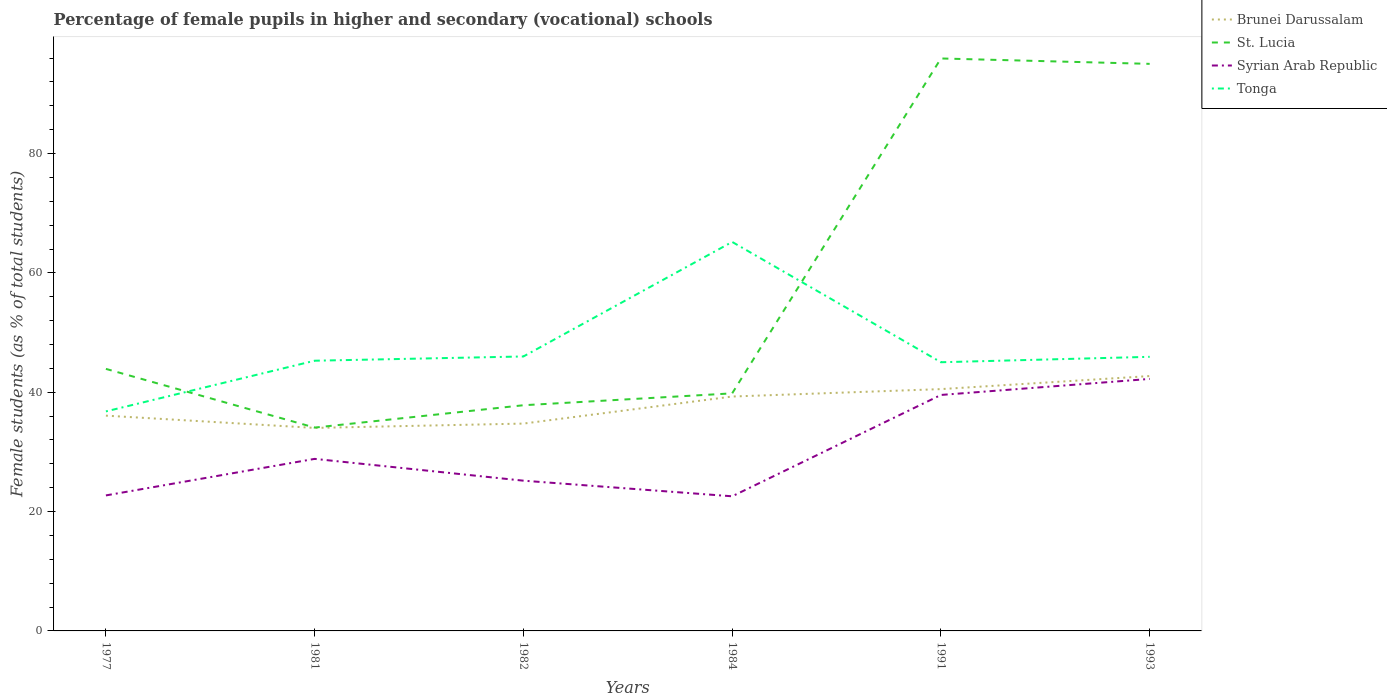How many different coloured lines are there?
Keep it short and to the point. 4. Across all years, what is the maximum percentage of female pupils in higher and secondary schools in St. Lucia?
Give a very brief answer. 34.08. In which year was the percentage of female pupils in higher and secondary schools in St. Lucia maximum?
Provide a short and direct response. 1981. What is the total percentage of female pupils in higher and secondary schools in St. Lucia in the graph?
Make the answer very short. -51.12. What is the difference between the highest and the second highest percentage of female pupils in higher and secondary schools in St. Lucia?
Make the answer very short. 61.86. What is the difference between the highest and the lowest percentage of female pupils in higher and secondary schools in Brunei Darussalam?
Offer a very short reply. 3. How many lines are there?
Make the answer very short. 4. Are the values on the major ticks of Y-axis written in scientific E-notation?
Provide a succinct answer. No. Does the graph contain grids?
Ensure brevity in your answer.  No. How many legend labels are there?
Offer a terse response. 4. What is the title of the graph?
Provide a short and direct response. Percentage of female pupils in higher and secondary (vocational) schools. Does "Italy" appear as one of the legend labels in the graph?
Your answer should be very brief. No. What is the label or title of the X-axis?
Provide a short and direct response. Years. What is the label or title of the Y-axis?
Provide a succinct answer. Female students (as % of total students). What is the Female students (as % of total students) in Brunei Darussalam in 1977?
Provide a succinct answer. 36.08. What is the Female students (as % of total students) in St. Lucia in 1977?
Give a very brief answer. 43.92. What is the Female students (as % of total students) of Syrian Arab Republic in 1977?
Give a very brief answer. 22.71. What is the Female students (as % of total students) in Tonga in 1977?
Your answer should be compact. 36.79. What is the Female students (as % of total students) of Brunei Darussalam in 1981?
Ensure brevity in your answer.  34.02. What is the Female students (as % of total students) of St. Lucia in 1981?
Provide a succinct answer. 34.08. What is the Female students (as % of total students) of Syrian Arab Republic in 1981?
Keep it short and to the point. 28.83. What is the Female students (as % of total students) of Tonga in 1981?
Offer a terse response. 45.29. What is the Female students (as % of total students) in Brunei Darussalam in 1982?
Your response must be concise. 34.75. What is the Female students (as % of total students) of St. Lucia in 1982?
Ensure brevity in your answer.  37.82. What is the Female students (as % of total students) of Syrian Arab Republic in 1982?
Make the answer very short. 25.18. What is the Female students (as % of total students) of Tonga in 1982?
Provide a short and direct response. 46. What is the Female students (as % of total students) in Brunei Darussalam in 1984?
Your response must be concise. 39.28. What is the Female students (as % of total students) in St. Lucia in 1984?
Provide a short and direct response. 39.81. What is the Female students (as % of total students) in Syrian Arab Republic in 1984?
Your response must be concise. 22.56. What is the Female students (as % of total students) of Tonga in 1984?
Your answer should be very brief. 65.19. What is the Female students (as % of total students) of Brunei Darussalam in 1991?
Give a very brief answer. 40.53. What is the Female students (as % of total students) of St. Lucia in 1991?
Ensure brevity in your answer.  95.94. What is the Female students (as % of total students) in Syrian Arab Republic in 1991?
Make the answer very short. 39.55. What is the Female students (as % of total students) in Tonga in 1991?
Your answer should be compact. 45.03. What is the Female students (as % of total students) of Brunei Darussalam in 1993?
Provide a short and direct response. 42.72. What is the Female students (as % of total students) in St. Lucia in 1993?
Make the answer very short. 95.04. What is the Female students (as % of total students) in Syrian Arab Republic in 1993?
Your response must be concise. 42.23. What is the Female students (as % of total students) of Tonga in 1993?
Offer a very short reply. 45.94. Across all years, what is the maximum Female students (as % of total students) of Brunei Darussalam?
Ensure brevity in your answer.  42.72. Across all years, what is the maximum Female students (as % of total students) of St. Lucia?
Offer a very short reply. 95.94. Across all years, what is the maximum Female students (as % of total students) in Syrian Arab Republic?
Ensure brevity in your answer.  42.23. Across all years, what is the maximum Female students (as % of total students) in Tonga?
Make the answer very short. 65.19. Across all years, what is the minimum Female students (as % of total students) of Brunei Darussalam?
Keep it short and to the point. 34.02. Across all years, what is the minimum Female students (as % of total students) in St. Lucia?
Your answer should be compact. 34.08. Across all years, what is the minimum Female students (as % of total students) in Syrian Arab Republic?
Provide a succinct answer. 22.56. Across all years, what is the minimum Female students (as % of total students) of Tonga?
Keep it short and to the point. 36.79. What is the total Female students (as % of total students) in Brunei Darussalam in the graph?
Keep it short and to the point. 227.38. What is the total Female students (as % of total students) of St. Lucia in the graph?
Give a very brief answer. 346.61. What is the total Female students (as % of total students) of Syrian Arab Republic in the graph?
Offer a very short reply. 181.07. What is the total Female students (as % of total students) in Tonga in the graph?
Make the answer very short. 284.24. What is the difference between the Female students (as % of total students) in Brunei Darussalam in 1977 and that in 1981?
Your answer should be compact. 2.06. What is the difference between the Female students (as % of total students) of St. Lucia in 1977 and that in 1981?
Your answer should be compact. 9.84. What is the difference between the Female students (as % of total students) in Syrian Arab Republic in 1977 and that in 1981?
Make the answer very short. -6.12. What is the difference between the Female students (as % of total students) of Tonga in 1977 and that in 1981?
Your answer should be compact. -8.49. What is the difference between the Female students (as % of total students) in Brunei Darussalam in 1977 and that in 1982?
Offer a very short reply. 1.33. What is the difference between the Female students (as % of total students) of St. Lucia in 1977 and that in 1982?
Ensure brevity in your answer.  6.09. What is the difference between the Female students (as % of total students) in Syrian Arab Republic in 1977 and that in 1982?
Offer a terse response. -2.47. What is the difference between the Female students (as % of total students) of Tonga in 1977 and that in 1982?
Your response must be concise. -9.21. What is the difference between the Female students (as % of total students) in Brunei Darussalam in 1977 and that in 1984?
Ensure brevity in your answer.  -3.2. What is the difference between the Female students (as % of total students) of St. Lucia in 1977 and that in 1984?
Make the answer very short. 4.1. What is the difference between the Female students (as % of total students) of Syrian Arab Republic in 1977 and that in 1984?
Your response must be concise. 0.15. What is the difference between the Female students (as % of total students) in Tonga in 1977 and that in 1984?
Give a very brief answer. -28.4. What is the difference between the Female students (as % of total students) of Brunei Darussalam in 1977 and that in 1991?
Your response must be concise. -4.45. What is the difference between the Female students (as % of total students) in St. Lucia in 1977 and that in 1991?
Keep it short and to the point. -52.02. What is the difference between the Female students (as % of total students) in Syrian Arab Republic in 1977 and that in 1991?
Your answer should be compact. -16.84. What is the difference between the Female students (as % of total students) in Tonga in 1977 and that in 1991?
Your response must be concise. -8.24. What is the difference between the Female students (as % of total students) of Brunei Darussalam in 1977 and that in 1993?
Make the answer very short. -6.64. What is the difference between the Female students (as % of total students) of St. Lucia in 1977 and that in 1993?
Your answer should be compact. -51.12. What is the difference between the Female students (as % of total students) of Syrian Arab Republic in 1977 and that in 1993?
Offer a terse response. -19.52. What is the difference between the Female students (as % of total students) of Tonga in 1977 and that in 1993?
Provide a succinct answer. -9.15. What is the difference between the Female students (as % of total students) of Brunei Darussalam in 1981 and that in 1982?
Your response must be concise. -0.73. What is the difference between the Female students (as % of total students) in St. Lucia in 1981 and that in 1982?
Provide a short and direct response. -3.75. What is the difference between the Female students (as % of total students) of Syrian Arab Republic in 1981 and that in 1982?
Your response must be concise. 3.65. What is the difference between the Female students (as % of total students) of Tonga in 1981 and that in 1982?
Your answer should be compact. -0.71. What is the difference between the Female students (as % of total students) in Brunei Darussalam in 1981 and that in 1984?
Your answer should be very brief. -5.26. What is the difference between the Female students (as % of total students) of St. Lucia in 1981 and that in 1984?
Your answer should be very brief. -5.74. What is the difference between the Female students (as % of total students) of Syrian Arab Republic in 1981 and that in 1984?
Provide a short and direct response. 6.27. What is the difference between the Female students (as % of total students) of Tonga in 1981 and that in 1984?
Give a very brief answer. -19.91. What is the difference between the Female students (as % of total students) of Brunei Darussalam in 1981 and that in 1991?
Offer a terse response. -6.5. What is the difference between the Female students (as % of total students) of St. Lucia in 1981 and that in 1991?
Your answer should be very brief. -61.86. What is the difference between the Female students (as % of total students) of Syrian Arab Republic in 1981 and that in 1991?
Keep it short and to the point. -10.71. What is the difference between the Female students (as % of total students) in Tonga in 1981 and that in 1991?
Give a very brief answer. 0.25. What is the difference between the Female students (as % of total students) of Brunei Darussalam in 1981 and that in 1993?
Provide a succinct answer. -8.69. What is the difference between the Female students (as % of total students) of St. Lucia in 1981 and that in 1993?
Keep it short and to the point. -60.96. What is the difference between the Female students (as % of total students) of Syrian Arab Republic in 1981 and that in 1993?
Offer a very short reply. -13.4. What is the difference between the Female students (as % of total students) of Tonga in 1981 and that in 1993?
Make the answer very short. -0.65. What is the difference between the Female students (as % of total students) of Brunei Darussalam in 1982 and that in 1984?
Make the answer very short. -4.53. What is the difference between the Female students (as % of total students) in St. Lucia in 1982 and that in 1984?
Give a very brief answer. -1.99. What is the difference between the Female students (as % of total students) in Syrian Arab Republic in 1982 and that in 1984?
Your response must be concise. 2.62. What is the difference between the Female students (as % of total students) in Tonga in 1982 and that in 1984?
Provide a short and direct response. -19.2. What is the difference between the Female students (as % of total students) of Brunei Darussalam in 1982 and that in 1991?
Your answer should be very brief. -5.78. What is the difference between the Female students (as % of total students) in St. Lucia in 1982 and that in 1991?
Keep it short and to the point. -58.12. What is the difference between the Female students (as % of total students) in Syrian Arab Republic in 1982 and that in 1991?
Offer a very short reply. -14.37. What is the difference between the Female students (as % of total students) in Tonga in 1982 and that in 1991?
Give a very brief answer. 0.97. What is the difference between the Female students (as % of total students) in Brunei Darussalam in 1982 and that in 1993?
Make the answer very short. -7.97. What is the difference between the Female students (as % of total students) in St. Lucia in 1982 and that in 1993?
Make the answer very short. -57.21. What is the difference between the Female students (as % of total students) in Syrian Arab Republic in 1982 and that in 1993?
Give a very brief answer. -17.05. What is the difference between the Female students (as % of total students) in Tonga in 1982 and that in 1993?
Ensure brevity in your answer.  0.06. What is the difference between the Female students (as % of total students) in Brunei Darussalam in 1984 and that in 1991?
Give a very brief answer. -1.24. What is the difference between the Female students (as % of total students) in St. Lucia in 1984 and that in 1991?
Offer a terse response. -56.13. What is the difference between the Female students (as % of total students) of Syrian Arab Republic in 1984 and that in 1991?
Your response must be concise. -16.98. What is the difference between the Female students (as % of total students) of Tonga in 1984 and that in 1991?
Your answer should be very brief. 20.16. What is the difference between the Female students (as % of total students) of Brunei Darussalam in 1984 and that in 1993?
Provide a succinct answer. -3.43. What is the difference between the Female students (as % of total students) in St. Lucia in 1984 and that in 1993?
Give a very brief answer. -55.22. What is the difference between the Female students (as % of total students) of Syrian Arab Republic in 1984 and that in 1993?
Offer a very short reply. -19.67. What is the difference between the Female students (as % of total students) in Tonga in 1984 and that in 1993?
Provide a short and direct response. 19.26. What is the difference between the Female students (as % of total students) in Brunei Darussalam in 1991 and that in 1993?
Provide a succinct answer. -2.19. What is the difference between the Female students (as % of total students) in St. Lucia in 1991 and that in 1993?
Provide a succinct answer. 0.9. What is the difference between the Female students (as % of total students) of Syrian Arab Republic in 1991 and that in 1993?
Ensure brevity in your answer.  -2.69. What is the difference between the Female students (as % of total students) of Tonga in 1991 and that in 1993?
Keep it short and to the point. -0.91. What is the difference between the Female students (as % of total students) of Brunei Darussalam in 1977 and the Female students (as % of total students) of St. Lucia in 1981?
Your answer should be very brief. 2. What is the difference between the Female students (as % of total students) of Brunei Darussalam in 1977 and the Female students (as % of total students) of Syrian Arab Republic in 1981?
Make the answer very short. 7.25. What is the difference between the Female students (as % of total students) of Brunei Darussalam in 1977 and the Female students (as % of total students) of Tonga in 1981?
Provide a short and direct response. -9.21. What is the difference between the Female students (as % of total students) of St. Lucia in 1977 and the Female students (as % of total students) of Syrian Arab Republic in 1981?
Your answer should be very brief. 15.08. What is the difference between the Female students (as % of total students) in St. Lucia in 1977 and the Female students (as % of total students) in Tonga in 1981?
Your answer should be very brief. -1.37. What is the difference between the Female students (as % of total students) in Syrian Arab Republic in 1977 and the Female students (as % of total students) in Tonga in 1981?
Ensure brevity in your answer.  -22.57. What is the difference between the Female students (as % of total students) of Brunei Darussalam in 1977 and the Female students (as % of total students) of St. Lucia in 1982?
Your answer should be compact. -1.74. What is the difference between the Female students (as % of total students) of Brunei Darussalam in 1977 and the Female students (as % of total students) of Syrian Arab Republic in 1982?
Offer a terse response. 10.9. What is the difference between the Female students (as % of total students) of Brunei Darussalam in 1977 and the Female students (as % of total students) of Tonga in 1982?
Offer a terse response. -9.92. What is the difference between the Female students (as % of total students) in St. Lucia in 1977 and the Female students (as % of total students) in Syrian Arab Republic in 1982?
Your response must be concise. 18.74. What is the difference between the Female students (as % of total students) in St. Lucia in 1977 and the Female students (as % of total students) in Tonga in 1982?
Your answer should be compact. -2.08. What is the difference between the Female students (as % of total students) of Syrian Arab Republic in 1977 and the Female students (as % of total students) of Tonga in 1982?
Your response must be concise. -23.29. What is the difference between the Female students (as % of total students) of Brunei Darussalam in 1977 and the Female students (as % of total students) of St. Lucia in 1984?
Your answer should be very brief. -3.73. What is the difference between the Female students (as % of total students) of Brunei Darussalam in 1977 and the Female students (as % of total students) of Syrian Arab Republic in 1984?
Your response must be concise. 13.52. What is the difference between the Female students (as % of total students) in Brunei Darussalam in 1977 and the Female students (as % of total students) in Tonga in 1984?
Ensure brevity in your answer.  -29.11. What is the difference between the Female students (as % of total students) in St. Lucia in 1977 and the Female students (as % of total students) in Syrian Arab Republic in 1984?
Your answer should be very brief. 21.35. What is the difference between the Female students (as % of total students) of St. Lucia in 1977 and the Female students (as % of total students) of Tonga in 1984?
Offer a very short reply. -21.28. What is the difference between the Female students (as % of total students) of Syrian Arab Republic in 1977 and the Female students (as % of total students) of Tonga in 1984?
Offer a very short reply. -42.48. What is the difference between the Female students (as % of total students) in Brunei Darussalam in 1977 and the Female students (as % of total students) in St. Lucia in 1991?
Offer a very short reply. -59.86. What is the difference between the Female students (as % of total students) of Brunei Darussalam in 1977 and the Female students (as % of total students) of Syrian Arab Republic in 1991?
Provide a succinct answer. -3.47. What is the difference between the Female students (as % of total students) in Brunei Darussalam in 1977 and the Female students (as % of total students) in Tonga in 1991?
Your response must be concise. -8.95. What is the difference between the Female students (as % of total students) of St. Lucia in 1977 and the Female students (as % of total students) of Syrian Arab Republic in 1991?
Give a very brief answer. 4.37. What is the difference between the Female students (as % of total students) of St. Lucia in 1977 and the Female students (as % of total students) of Tonga in 1991?
Your answer should be very brief. -1.11. What is the difference between the Female students (as % of total students) in Syrian Arab Republic in 1977 and the Female students (as % of total students) in Tonga in 1991?
Ensure brevity in your answer.  -22.32. What is the difference between the Female students (as % of total students) of Brunei Darussalam in 1977 and the Female students (as % of total students) of St. Lucia in 1993?
Your answer should be very brief. -58.96. What is the difference between the Female students (as % of total students) of Brunei Darussalam in 1977 and the Female students (as % of total students) of Syrian Arab Republic in 1993?
Offer a terse response. -6.15. What is the difference between the Female students (as % of total students) in Brunei Darussalam in 1977 and the Female students (as % of total students) in Tonga in 1993?
Your answer should be very brief. -9.86. What is the difference between the Female students (as % of total students) in St. Lucia in 1977 and the Female students (as % of total students) in Syrian Arab Republic in 1993?
Ensure brevity in your answer.  1.68. What is the difference between the Female students (as % of total students) in St. Lucia in 1977 and the Female students (as % of total students) in Tonga in 1993?
Your answer should be very brief. -2.02. What is the difference between the Female students (as % of total students) of Syrian Arab Republic in 1977 and the Female students (as % of total students) of Tonga in 1993?
Provide a succinct answer. -23.23. What is the difference between the Female students (as % of total students) in Brunei Darussalam in 1981 and the Female students (as % of total students) in St. Lucia in 1982?
Give a very brief answer. -3.8. What is the difference between the Female students (as % of total students) of Brunei Darussalam in 1981 and the Female students (as % of total students) of Syrian Arab Republic in 1982?
Provide a succinct answer. 8.84. What is the difference between the Female students (as % of total students) in Brunei Darussalam in 1981 and the Female students (as % of total students) in Tonga in 1982?
Offer a terse response. -11.97. What is the difference between the Female students (as % of total students) in St. Lucia in 1981 and the Female students (as % of total students) in Syrian Arab Republic in 1982?
Give a very brief answer. 8.9. What is the difference between the Female students (as % of total students) in St. Lucia in 1981 and the Female students (as % of total students) in Tonga in 1982?
Provide a short and direct response. -11.92. What is the difference between the Female students (as % of total students) in Syrian Arab Republic in 1981 and the Female students (as % of total students) in Tonga in 1982?
Your response must be concise. -17.16. What is the difference between the Female students (as % of total students) of Brunei Darussalam in 1981 and the Female students (as % of total students) of St. Lucia in 1984?
Your response must be concise. -5.79. What is the difference between the Female students (as % of total students) in Brunei Darussalam in 1981 and the Female students (as % of total students) in Syrian Arab Republic in 1984?
Make the answer very short. 11.46. What is the difference between the Female students (as % of total students) in Brunei Darussalam in 1981 and the Female students (as % of total students) in Tonga in 1984?
Provide a short and direct response. -31.17. What is the difference between the Female students (as % of total students) of St. Lucia in 1981 and the Female students (as % of total students) of Syrian Arab Republic in 1984?
Offer a terse response. 11.52. What is the difference between the Female students (as % of total students) of St. Lucia in 1981 and the Female students (as % of total students) of Tonga in 1984?
Keep it short and to the point. -31.12. What is the difference between the Female students (as % of total students) of Syrian Arab Republic in 1981 and the Female students (as % of total students) of Tonga in 1984?
Give a very brief answer. -36.36. What is the difference between the Female students (as % of total students) in Brunei Darussalam in 1981 and the Female students (as % of total students) in St. Lucia in 1991?
Give a very brief answer. -61.92. What is the difference between the Female students (as % of total students) of Brunei Darussalam in 1981 and the Female students (as % of total students) of Syrian Arab Republic in 1991?
Your answer should be compact. -5.52. What is the difference between the Female students (as % of total students) of Brunei Darussalam in 1981 and the Female students (as % of total students) of Tonga in 1991?
Make the answer very short. -11.01. What is the difference between the Female students (as % of total students) of St. Lucia in 1981 and the Female students (as % of total students) of Syrian Arab Republic in 1991?
Your answer should be compact. -5.47. What is the difference between the Female students (as % of total students) of St. Lucia in 1981 and the Female students (as % of total students) of Tonga in 1991?
Your response must be concise. -10.95. What is the difference between the Female students (as % of total students) of Syrian Arab Republic in 1981 and the Female students (as % of total students) of Tonga in 1991?
Provide a succinct answer. -16.2. What is the difference between the Female students (as % of total students) in Brunei Darussalam in 1981 and the Female students (as % of total students) in St. Lucia in 1993?
Keep it short and to the point. -61.01. What is the difference between the Female students (as % of total students) in Brunei Darussalam in 1981 and the Female students (as % of total students) in Syrian Arab Republic in 1993?
Your answer should be compact. -8.21. What is the difference between the Female students (as % of total students) of Brunei Darussalam in 1981 and the Female students (as % of total students) of Tonga in 1993?
Your answer should be compact. -11.92. What is the difference between the Female students (as % of total students) of St. Lucia in 1981 and the Female students (as % of total students) of Syrian Arab Republic in 1993?
Your answer should be compact. -8.16. What is the difference between the Female students (as % of total students) of St. Lucia in 1981 and the Female students (as % of total students) of Tonga in 1993?
Provide a succinct answer. -11.86. What is the difference between the Female students (as % of total students) of Syrian Arab Republic in 1981 and the Female students (as % of total students) of Tonga in 1993?
Ensure brevity in your answer.  -17.1. What is the difference between the Female students (as % of total students) in Brunei Darussalam in 1982 and the Female students (as % of total students) in St. Lucia in 1984?
Offer a very short reply. -5.07. What is the difference between the Female students (as % of total students) in Brunei Darussalam in 1982 and the Female students (as % of total students) in Syrian Arab Republic in 1984?
Keep it short and to the point. 12.19. What is the difference between the Female students (as % of total students) in Brunei Darussalam in 1982 and the Female students (as % of total students) in Tonga in 1984?
Provide a succinct answer. -30.45. What is the difference between the Female students (as % of total students) in St. Lucia in 1982 and the Female students (as % of total students) in Syrian Arab Republic in 1984?
Give a very brief answer. 15.26. What is the difference between the Female students (as % of total students) in St. Lucia in 1982 and the Female students (as % of total students) in Tonga in 1984?
Your answer should be very brief. -27.37. What is the difference between the Female students (as % of total students) of Syrian Arab Republic in 1982 and the Female students (as % of total students) of Tonga in 1984?
Give a very brief answer. -40.01. What is the difference between the Female students (as % of total students) of Brunei Darussalam in 1982 and the Female students (as % of total students) of St. Lucia in 1991?
Your answer should be compact. -61.19. What is the difference between the Female students (as % of total students) of Brunei Darussalam in 1982 and the Female students (as % of total students) of Syrian Arab Republic in 1991?
Offer a very short reply. -4.8. What is the difference between the Female students (as % of total students) in Brunei Darussalam in 1982 and the Female students (as % of total students) in Tonga in 1991?
Your answer should be very brief. -10.28. What is the difference between the Female students (as % of total students) in St. Lucia in 1982 and the Female students (as % of total students) in Syrian Arab Republic in 1991?
Give a very brief answer. -1.72. What is the difference between the Female students (as % of total students) of St. Lucia in 1982 and the Female students (as % of total students) of Tonga in 1991?
Provide a succinct answer. -7.21. What is the difference between the Female students (as % of total students) of Syrian Arab Republic in 1982 and the Female students (as % of total students) of Tonga in 1991?
Give a very brief answer. -19.85. What is the difference between the Female students (as % of total students) in Brunei Darussalam in 1982 and the Female students (as % of total students) in St. Lucia in 1993?
Offer a very short reply. -60.29. What is the difference between the Female students (as % of total students) of Brunei Darussalam in 1982 and the Female students (as % of total students) of Syrian Arab Republic in 1993?
Offer a terse response. -7.49. What is the difference between the Female students (as % of total students) of Brunei Darussalam in 1982 and the Female students (as % of total students) of Tonga in 1993?
Your response must be concise. -11.19. What is the difference between the Female students (as % of total students) of St. Lucia in 1982 and the Female students (as % of total students) of Syrian Arab Republic in 1993?
Provide a succinct answer. -4.41. What is the difference between the Female students (as % of total students) of St. Lucia in 1982 and the Female students (as % of total students) of Tonga in 1993?
Make the answer very short. -8.11. What is the difference between the Female students (as % of total students) of Syrian Arab Republic in 1982 and the Female students (as % of total students) of Tonga in 1993?
Provide a succinct answer. -20.76. What is the difference between the Female students (as % of total students) of Brunei Darussalam in 1984 and the Female students (as % of total students) of St. Lucia in 1991?
Your answer should be compact. -56.66. What is the difference between the Female students (as % of total students) in Brunei Darussalam in 1984 and the Female students (as % of total students) in Syrian Arab Republic in 1991?
Your answer should be compact. -0.26. What is the difference between the Female students (as % of total students) in Brunei Darussalam in 1984 and the Female students (as % of total students) in Tonga in 1991?
Make the answer very short. -5.75. What is the difference between the Female students (as % of total students) of St. Lucia in 1984 and the Female students (as % of total students) of Syrian Arab Republic in 1991?
Make the answer very short. 0.27. What is the difference between the Female students (as % of total students) in St. Lucia in 1984 and the Female students (as % of total students) in Tonga in 1991?
Give a very brief answer. -5.22. What is the difference between the Female students (as % of total students) of Syrian Arab Republic in 1984 and the Female students (as % of total students) of Tonga in 1991?
Your answer should be compact. -22.47. What is the difference between the Female students (as % of total students) in Brunei Darussalam in 1984 and the Female students (as % of total students) in St. Lucia in 1993?
Offer a very short reply. -55.75. What is the difference between the Female students (as % of total students) in Brunei Darussalam in 1984 and the Female students (as % of total students) in Syrian Arab Republic in 1993?
Offer a terse response. -2.95. What is the difference between the Female students (as % of total students) in Brunei Darussalam in 1984 and the Female students (as % of total students) in Tonga in 1993?
Give a very brief answer. -6.65. What is the difference between the Female students (as % of total students) in St. Lucia in 1984 and the Female students (as % of total students) in Syrian Arab Republic in 1993?
Ensure brevity in your answer.  -2.42. What is the difference between the Female students (as % of total students) in St. Lucia in 1984 and the Female students (as % of total students) in Tonga in 1993?
Your answer should be very brief. -6.12. What is the difference between the Female students (as % of total students) of Syrian Arab Republic in 1984 and the Female students (as % of total students) of Tonga in 1993?
Offer a terse response. -23.37. What is the difference between the Female students (as % of total students) in Brunei Darussalam in 1991 and the Female students (as % of total students) in St. Lucia in 1993?
Keep it short and to the point. -54.51. What is the difference between the Female students (as % of total students) of Brunei Darussalam in 1991 and the Female students (as % of total students) of Syrian Arab Republic in 1993?
Your answer should be compact. -1.71. What is the difference between the Female students (as % of total students) in Brunei Darussalam in 1991 and the Female students (as % of total students) in Tonga in 1993?
Ensure brevity in your answer.  -5.41. What is the difference between the Female students (as % of total students) of St. Lucia in 1991 and the Female students (as % of total students) of Syrian Arab Republic in 1993?
Ensure brevity in your answer.  53.71. What is the difference between the Female students (as % of total students) in St. Lucia in 1991 and the Female students (as % of total students) in Tonga in 1993?
Your answer should be compact. 50. What is the difference between the Female students (as % of total students) in Syrian Arab Republic in 1991 and the Female students (as % of total students) in Tonga in 1993?
Offer a terse response. -6.39. What is the average Female students (as % of total students) in Brunei Darussalam per year?
Offer a very short reply. 37.9. What is the average Female students (as % of total students) of St. Lucia per year?
Keep it short and to the point. 57.77. What is the average Female students (as % of total students) of Syrian Arab Republic per year?
Your answer should be very brief. 30.18. What is the average Female students (as % of total students) of Tonga per year?
Ensure brevity in your answer.  47.37. In the year 1977, what is the difference between the Female students (as % of total students) of Brunei Darussalam and Female students (as % of total students) of St. Lucia?
Keep it short and to the point. -7.84. In the year 1977, what is the difference between the Female students (as % of total students) of Brunei Darussalam and Female students (as % of total students) of Syrian Arab Republic?
Your answer should be very brief. 13.37. In the year 1977, what is the difference between the Female students (as % of total students) of Brunei Darussalam and Female students (as % of total students) of Tonga?
Offer a very short reply. -0.71. In the year 1977, what is the difference between the Female students (as % of total students) of St. Lucia and Female students (as % of total students) of Syrian Arab Republic?
Your response must be concise. 21.21. In the year 1977, what is the difference between the Female students (as % of total students) of St. Lucia and Female students (as % of total students) of Tonga?
Ensure brevity in your answer.  7.13. In the year 1977, what is the difference between the Female students (as % of total students) of Syrian Arab Republic and Female students (as % of total students) of Tonga?
Your response must be concise. -14.08. In the year 1981, what is the difference between the Female students (as % of total students) of Brunei Darussalam and Female students (as % of total students) of St. Lucia?
Your response must be concise. -0.06. In the year 1981, what is the difference between the Female students (as % of total students) in Brunei Darussalam and Female students (as % of total students) in Syrian Arab Republic?
Offer a very short reply. 5.19. In the year 1981, what is the difference between the Female students (as % of total students) of Brunei Darussalam and Female students (as % of total students) of Tonga?
Make the answer very short. -11.26. In the year 1981, what is the difference between the Female students (as % of total students) of St. Lucia and Female students (as % of total students) of Syrian Arab Republic?
Ensure brevity in your answer.  5.24. In the year 1981, what is the difference between the Female students (as % of total students) in St. Lucia and Female students (as % of total students) in Tonga?
Ensure brevity in your answer.  -11.21. In the year 1981, what is the difference between the Female students (as % of total students) in Syrian Arab Republic and Female students (as % of total students) in Tonga?
Make the answer very short. -16.45. In the year 1982, what is the difference between the Female students (as % of total students) in Brunei Darussalam and Female students (as % of total students) in St. Lucia?
Provide a succinct answer. -3.07. In the year 1982, what is the difference between the Female students (as % of total students) in Brunei Darussalam and Female students (as % of total students) in Syrian Arab Republic?
Keep it short and to the point. 9.57. In the year 1982, what is the difference between the Female students (as % of total students) of Brunei Darussalam and Female students (as % of total students) of Tonga?
Keep it short and to the point. -11.25. In the year 1982, what is the difference between the Female students (as % of total students) in St. Lucia and Female students (as % of total students) in Syrian Arab Republic?
Provide a short and direct response. 12.64. In the year 1982, what is the difference between the Female students (as % of total students) of St. Lucia and Female students (as % of total students) of Tonga?
Your answer should be very brief. -8.17. In the year 1982, what is the difference between the Female students (as % of total students) of Syrian Arab Republic and Female students (as % of total students) of Tonga?
Provide a short and direct response. -20.82. In the year 1984, what is the difference between the Female students (as % of total students) of Brunei Darussalam and Female students (as % of total students) of St. Lucia?
Offer a terse response. -0.53. In the year 1984, what is the difference between the Female students (as % of total students) in Brunei Darussalam and Female students (as % of total students) in Syrian Arab Republic?
Provide a short and direct response. 16.72. In the year 1984, what is the difference between the Female students (as % of total students) in Brunei Darussalam and Female students (as % of total students) in Tonga?
Your answer should be compact. -25.91. In the year 1984, what is the difference between the Female students (as % of total students) in St. Lucia and Female students (as % of total students) in Syrian Arab Republic?
Give a very brief answer. 17.25. In the year 1984, what is the difference between the Female students (as % of total students) of St. Lucia and Female students (as % of total students) of Tonga?
Give a very brief answer. -25.38. In the year 1984, what is the difference between the Female students (as % of total students) of Syrian Arab Republic and Female students (as % of total students) of Tonga?
Keep it short and to the point. -42.63. In the year 1991, what is the difference between the Female students (as % of total students) of Brunei Darussalam and Female students (as % of total students) of St. Lucia?
Make the answer very short. -55.41. In the year 1991, what is the difference between the Female students (as % of total students) in Brunei Darussalam and Female students (as % of total students) in Syrian Arab Republic?
Your response must be concise. 0.98. In the year 1991, what is the difference between the Female students (as % of total students) of Brunei Darussalam and Female students (as % of total students) of Tonga?
Keep it short and to the point. -4.5. In the year 1991, what is the difference between the Female students (as % of total students) in St. Lucia and Female students (as % of total students) in Syrian Arab Republic?
Your answer should be very brief. 56.39. In the year 1991, what is the difference between the Female students (as % of total students) of St. Lucia and Female students (as % of total students) of Tonga?
Provide a short and direct response. 50.91. In the year 1991, what is the difference between the Female students (as % of total students) of Syrian Arab Republic and Female students (as % of total students) of Tonga?
Make the answer very short. -5.48. In the year 1993, what is the difference between the Female students (as % of total students) of Brunei Darussalam and Female students (as % of total students) of St. Lucia?
Keep it short and to the point. -52.32. In the year 1993, what is the difference between the Female students (as % of total students) of Brunei Darussalam and Female students (as % of total students) of Syrian Arab Republic?
Ensure brevity in your answer.  0.48. In the year 1993, what is the difference between the Female students (as % of total students) of Brunei Darussalam and Female students (as % of total students) of Tonga?
Provide a succinct answer. -3.22. In the year 1993, what is the difference between the Female students (as % of total students) in St. Lucia and Female students (as % of total students) in Syrian Arab Republic?
Offer a very short reply. 52.8. In the year 1993, what is the difference between the Female students (as % of total students) of St. Lucia and Female students (as % of total students) of Tonga?
Ensure brevity in your answer.  49.1. In the year 1993, what is the difference between the Female students (as % of total students) in Syrian Arab Republic and Female students (as % of total students) in Tonga?
Give a very brief answer. -3.7. What is the ratio of the Female students (as % of total students) of Brunei Darussalam in 1977 to that in 1981?
Keep it short and to the point. 1.06. What is the ratio of the Female students (as % of total students) of St. Lucia in 1977 to that in 1981?
Offer a terse response. 1.29. What is the ratio of the Female students (as % of total students) of Syrian Arab Republic in 1977 to that in 1981?
Keep it short and to the point. 0.79. What is the ratio of the Female students (as % of total students) in Tonga in 1977 to that in 1981?
Offer a very short reply. 0.81. What is the ratio of the Female students (as % of total students) in Brunei Darussalam in 1977 to that in 1982?
Your answer should be compact. 1.04. What is the ratio of the Female students (as % of total students) in St. Lucia in 1977 to that in 1982?
Provide a short and direct response. 1.16. What is the ratio of the Female students (as % of total students) of Syrian Arab Republic in 1977 to that in 1982?
Provide a short and direct response. 0.9. What is the ratio of the Female students (as % of total students) of Tonga in 1977 to that in 1982?
Provide a succinct answer. 0.8. What is the ratio of the Female students (as % of total students) in Brunei Darussalam in 1977 to that in 1984?
Keep it short and to the point. 0.92. What is the ratio of the Female students (as % of total students) in St. Lucia in 1977 to that in 1984?
Your response must be concise. 1.1. What is the ratio of the Female students (as % of total students) in Tonga in 1977 to that in 1984?
Make the answer very short. 0.56. What is the ratio of the Female students (as % of total students) of Brunei Darussalam in 1977 to that in 1991?
Your response must be concise. 0.89. What is the ratio of the Female students (as % of total students) of St. Lucia in 1977 to that in 1991?
Your answer should be compact. 0.46. What is the ratio of the Female students (as % of total students) of Syrian Arab Republic in 1977 to that in 1991?
Your answer should be very brief. 0.57. What is the ratio of the Female students (as % of total students) in Tonga in 1977 to that in 1991?
Your response must be concise. 0.82. What is the ratio of the Female students (as % of total students) of Brunei Darussalam in 1977 to that in 1993?
Your answer should be compact. 0.84. What is the ratio of the Female students (as % of total students) in St. Lucia in 1977 to that in 1993?
Keep it short and to the point. 0.46. What is the ratio of the Female students (as % of total students) in Syrian Arab Republic in 1977 to that in 1993?
Provide a short and direct response. 0.54. What is the ratio of the Female students (as % of total students) of Tonga in 1977 to that in 1993?
Keep it short and to the point. 0.8. What is the ratio of the Female students (as % of total students) in Brunei Darussalam in 1981 to that in 1982?
Your answer should be compact. 0.98. What is the ratio of the Female students (as % of total students) of St. Lucia in 1981 to that in 1982?
Offer a terse response. 0.9. What is the ratio of the Female students (as % of total students) of Syrian Arab Republic in 1981 to that in 1982?
Provide a succinct answer. 1.15. What is the ratio of the Female students (as % of total students) in Tonga in 1981 to that in 1982?
Provide a short and direct response. 0.98. What is the ratio of the Female students (as % of total students) of Brunei Darussalam in 1981 to that in 1984?
Ensure brevity in your answer.  0.87. What is the ratio of the Female students (as % of total students) of St. Lucia in 1981 to that in 1984?
Keep it short and to the point. 0.86. What is the ratio of the Female students (as % of total students) of Syrian Arab Republic in 1981 to that in 1984?
Ensure brevity in your answer.  1.28. What is the ratio of the Female students (as % of total students) in Tonga in 1981 to that in 1984?
Provide a succinct answer. 0.69. What is the ratio of the Female students (as % of total students) of Brunei Darussalam in 1981 to that in 1991?
Your response must be concise. 0.84. What is the ratio of the Female students (as % of total students) of St. Lucia in 1981 to that in 1991?
Ensure brevity in your answer.  0.36. What is the ratio of the Female students (as % of total students) of Syrian Arab Republic in 1981 to that in 1991?
Offer a terse response. 0.73. What is the ratio of the Female students (as % of total students) of Tonga in 1981 to that in 1991?
Ensure brevity in your answer.  1.01. What is the ratio of the Female students (as % of total students) of Brunei Darussalam in 1981 to that in 1993?
Offer a very short reply. 0.8. What is the ratio of the Female students (as % of total students) in St. Lucia in 1981 to that in 1993?
Provide a short and direct response. 0.36. What is the ratio of the Female students (as % of total students) in Syrian Arab Republic in 1981 to that in 1993?
Your answer should be compact. 0.68. What is the ratio of the Female students (as % of total students) in Tonga in 1981 to that in 1993?
Your response must be concise. 0.99. What is the ratio of the Female students (as % of total students) in Brunei Darussalam in 1982 to that in 1984?
Make the answer very short. 0.88. What is the ratio of the Female students (as % of total students) of St. Lucia in 1982 to that in 1984?
Your response must be concise. 0.95. What is the ratio of the Female students (as % of total students) of Syrian Arab Republic in 1982 to that in 1984?
Provide a short and direct response. 1.12. What is the ratio of the Female students (as % of total students) in Tonga in 1982 to that in 1984?
Your answer should be compact. 0.71. What is the ratio of the Female students (as % of total students) in Brunei Darussalam in 1982 to that in 1991?
Provide a short and direct response. 0.86. What is the ratio of the Female students (as % of total students) of St. Lucia in 1982 to that in 1991?
Give a very brief answer. 0.39. What is the ratio of the Female students (as % of total students) of Syrian Arab Republic in 1982 to that in 1991?
Make the answer very short. 0.64. What is the ratio of the Female students (as % of total students) of Tonga in 1982 to that in 1991?
Your answer should be very brief. 1.02. What is the ratio of the Female students (as % of total students) of Brunei Darussalam in 1982 to that in 1993?
Offer a very short reply. 0.81. What is the ratio of the Female students (as % of total students) of St. Lucia in 1982 to that in 1993?
Your response must be concise. 0.4. What is the ratio of the Female students (as % of total students) of Syrian Arab Republic in 1982 to that in 1993?
Offer a very short reply. 0.6. What is the ratio of the Female students (as % of total students) of Tonga in 1982 to that in 1993?
Your answer should be compact. 1. What is the ratio of the Female students (as % of total students) in Brunei Darussalam in 1984 to that in 1991?
Provide a short and direct response. 0.97. What is the ratio of the Female students (as % of total students) in St. Lucia in 1984 to that in 1991?
Offer a very short reply. 0.41. What is the ratio of the Female students (as % of total students) in Syrian Arab Republic in 1984 to that in 1991?
Offer a terse response. 0.57. What is the ratio of the Female students (as % of total students) of Tonga in 1984 to that in 1991?
Keep it short and to the point. 1.45. What is the ratio of the Female students (as % of total students) in Brunei Darussalam in 1984 to that in 1993?
Your answer should be very brief. 0.92. What is the ratio of the Female students (as % of total students) in St. Lucia in 1984 to that in 1993?
Give a very brief answer. 0.42. What is the ratio of the Female students (as % of total students) in Syrian Arab Republic in 1984 to that in 1993?
Your response must be concise. 0.53. What is the ratio of the Female students (as % of total students) in Tonga in 1984 to that in 1993?
Your response must be concise. 1.42. What is the ratio of the Female students (as % of total students) in Brunei Darussalam in 1991 to that in 1993?
Keep it short and to the point. 0.95. What is the ratio of the Female students (as % of total students) in St. Lucia in 1991 to that in 1993?
Provide a short and direct response. 1.01. What is the ratio of the Female students (as % of total students) of Syrian Arab Republic in 1991 to that in 1993?
Offer a terse response. 0.94. What is the ratio of the Female students (as % of total students) in Tonga in 1991 to that in 1993?
Provide a succinct answer. 0.98. What is the difference between the highest and the second highest Female students (as % of total students) in Brunei Darussalam?
Offer a terse response. 2.19. What is the difference between the highest and the second highest Female students (as % of total students) in St. Lucia?
Your answer should be compact. 0.9. What is the difference between the highest and the second highest Female students (as % of total students) of Syrian Arab Republic?
Your answer should be very brief. 2.69. What is the difference between the highest and the second highest Female students (as % of total students) of Tonga?
Provide a short and direct response. 19.2. What is the difference between the highest and the lowest Female students (as % of total students) in Brunei Darussalam?
Keep it short and to the point. 8.69. What is the difference between the highest and the lowest Female students (as % of total students) in St. Lucia?
Give a very brief answer. 61.86. What is the difference between the highest and the lowest Female students (as % of total students) in Syrian Arab Republic?
Make the answer very short. 19.67. What is the difference between the highest and the lowest Female students (as % of total students) of Tonga?
Your answer should be compact. 28.4. 